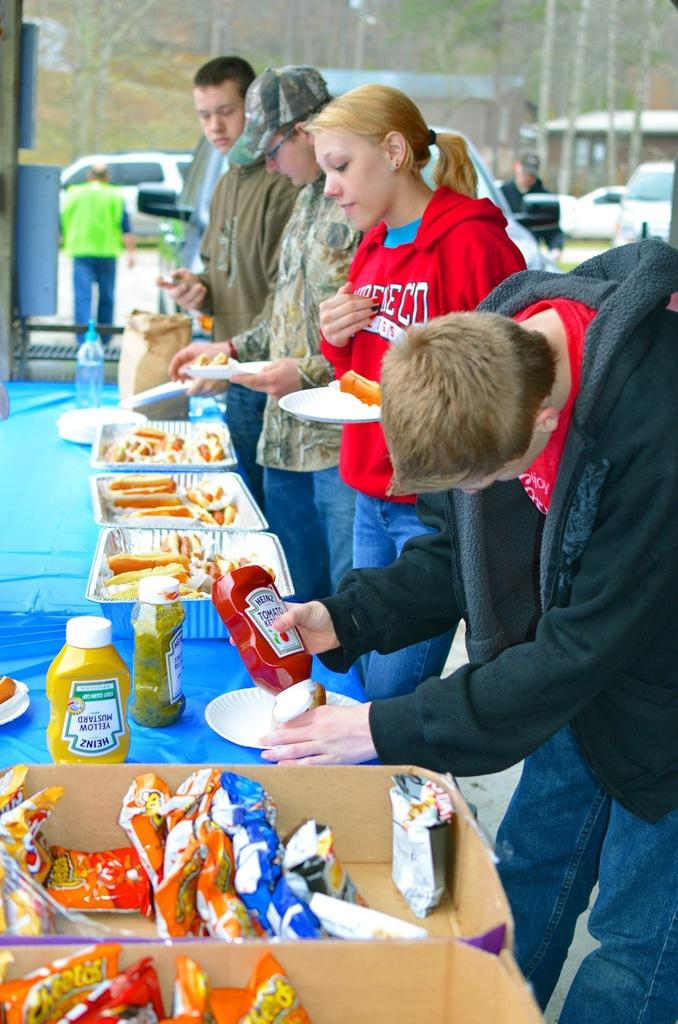What is present in the image that people typically use for eating or placing items? There is a table in the image. What is on the table? There are food items on the table, and they are in trays. Who might be interacting with the food items on the table? There are people standing in front of the table. What can be seen in the distance behind the table? There are cars in the background of the image, and the background is blurred. How many pigs are visible on the table in the image? There are no pigs present on the table in the image. What type of butter is being used to prepare the food on the table? There is no butter mentioned or visible in the image. 